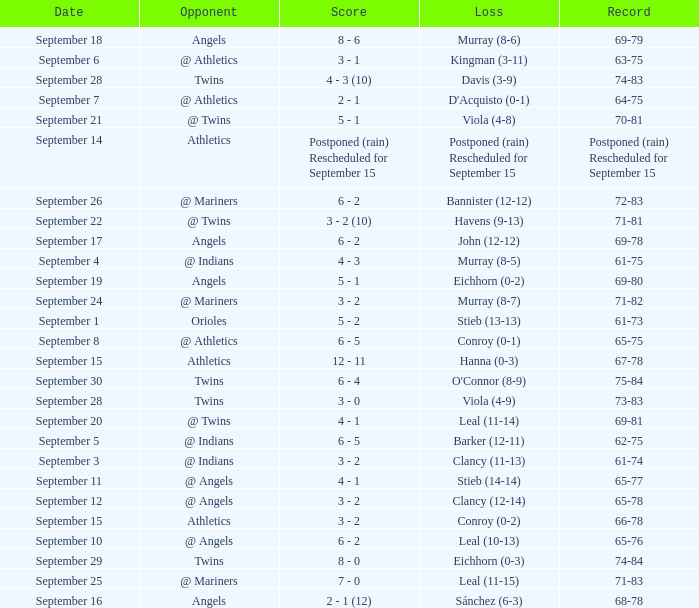Name the score which has record of 73-83 3 - 0. 